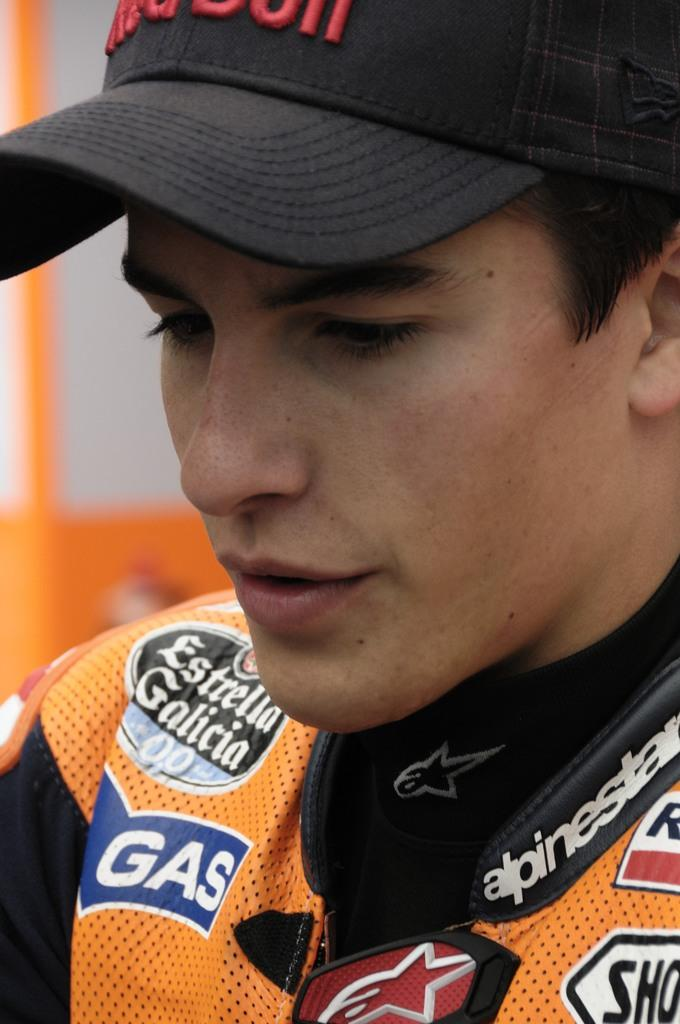Provide a one-sentence caption for the provided image. The blue tag on the persons shirt says gas. 